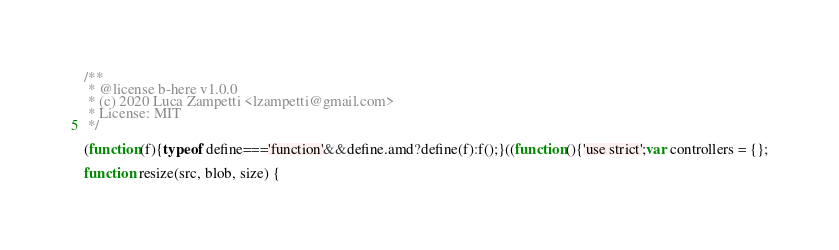Convert code to text. <code><loc_0><loc_0><loc_500><loc_500><_JavaScript_>/**
 * @license b-here v1.0.0
 * (c) 2020 Luca Zampetti <lzampetti@gmail.com>
 * License: MIT
 */

(function(f){typeof define==='function'&&define.amd?define(f):f();}((function(){'use strict';var controllers = {};

function resize(src, blob, size) {</code> 